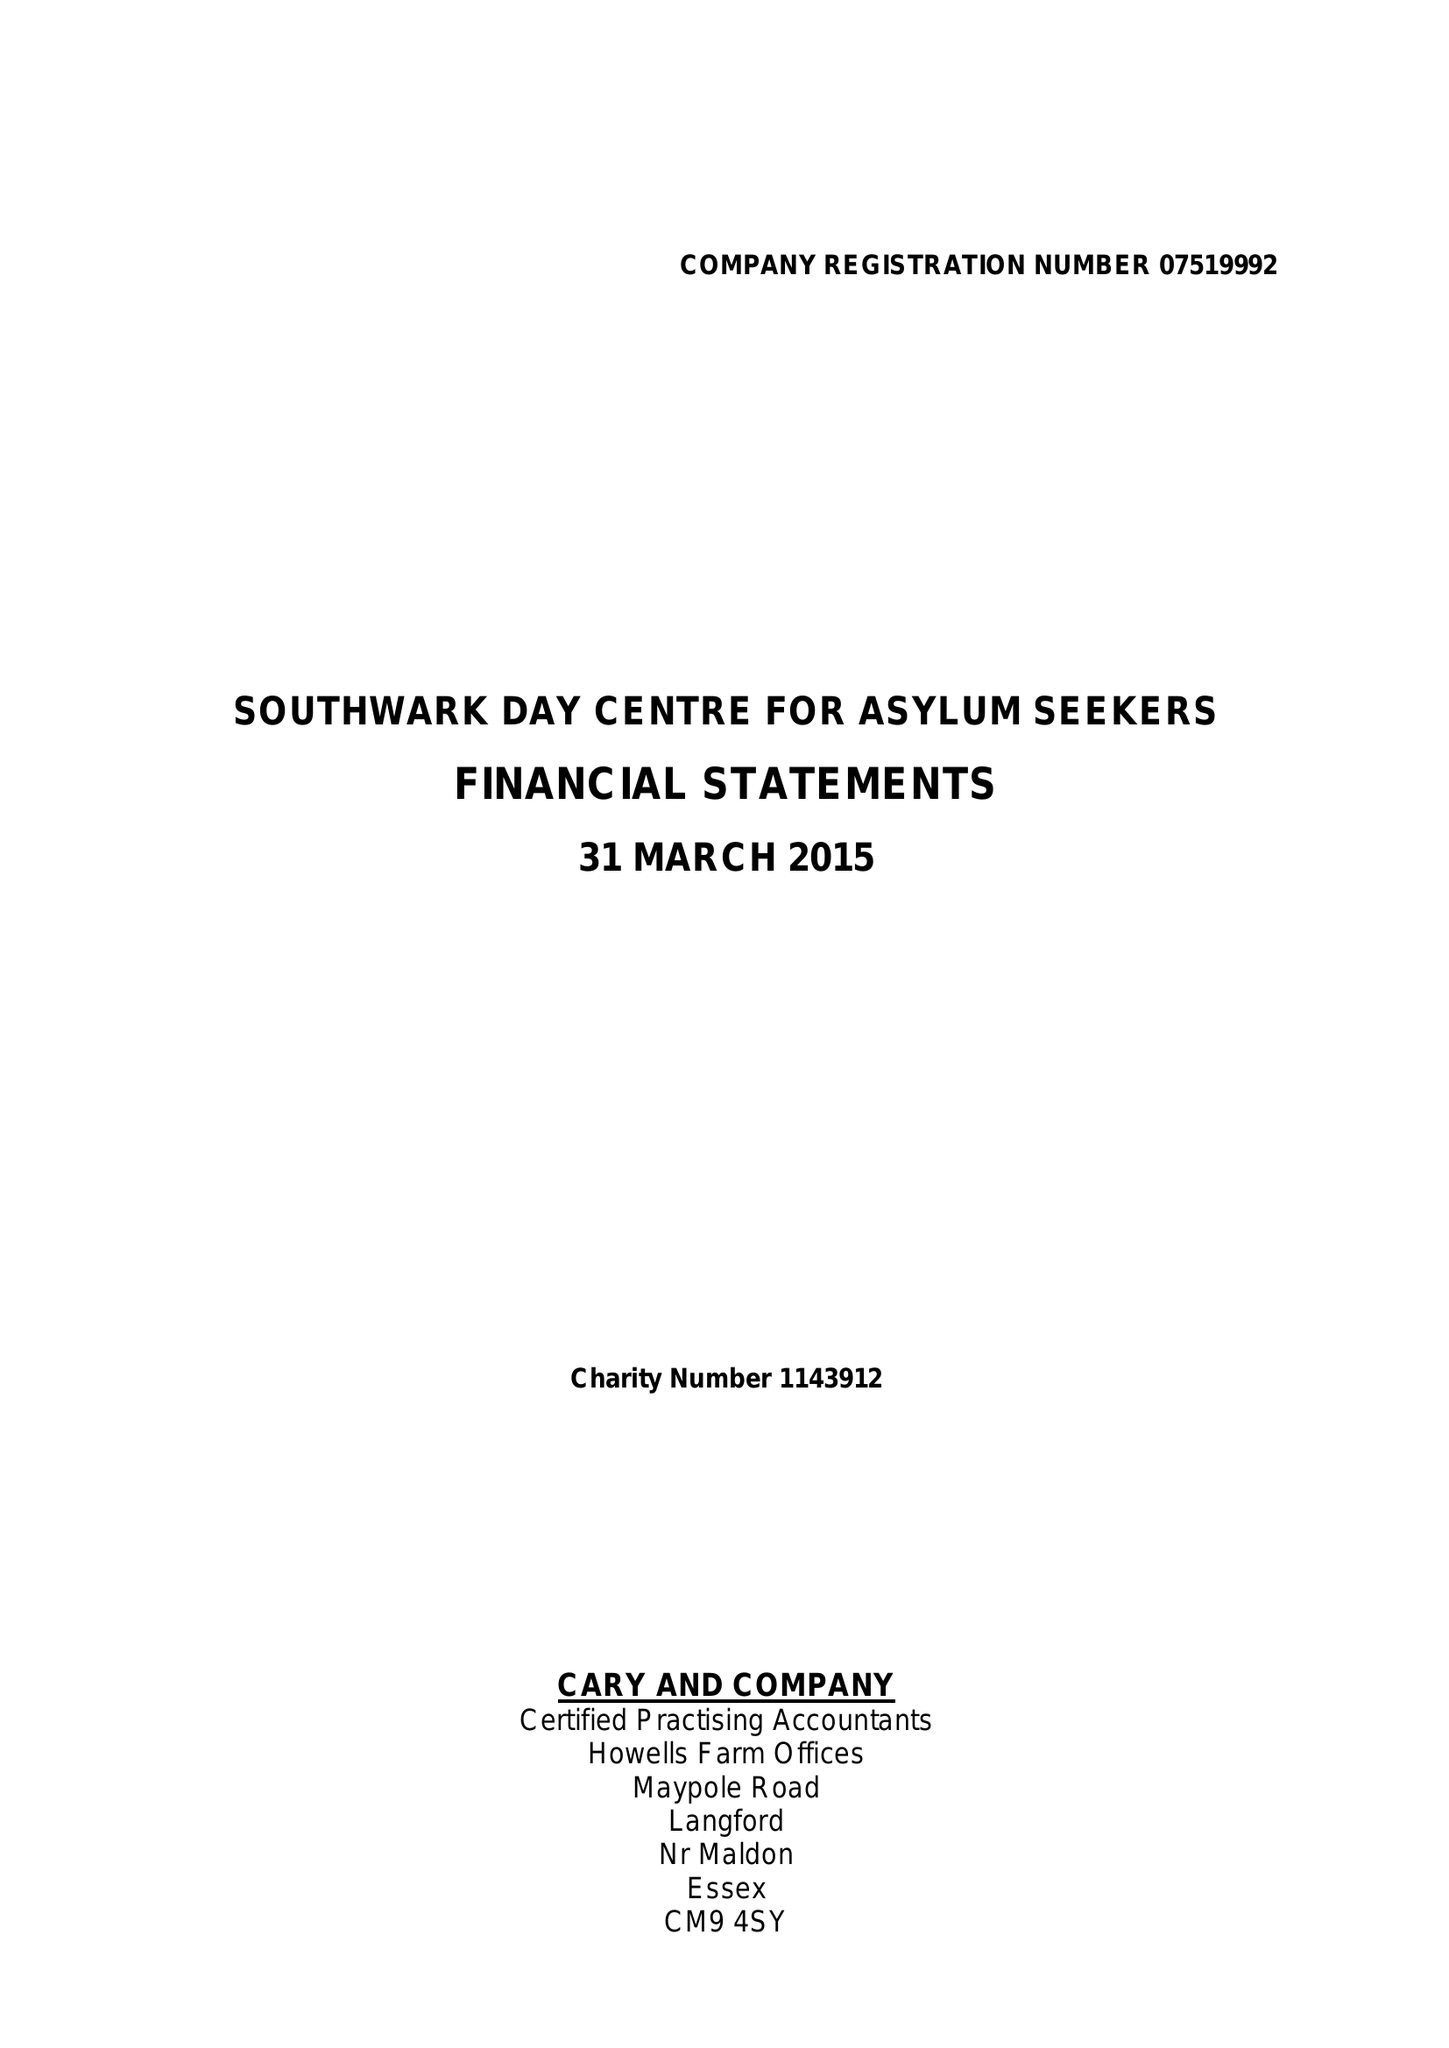What is the value for the income_annually_in_british_pounds?
Answer the question using a single word or phrase. 198520.00 